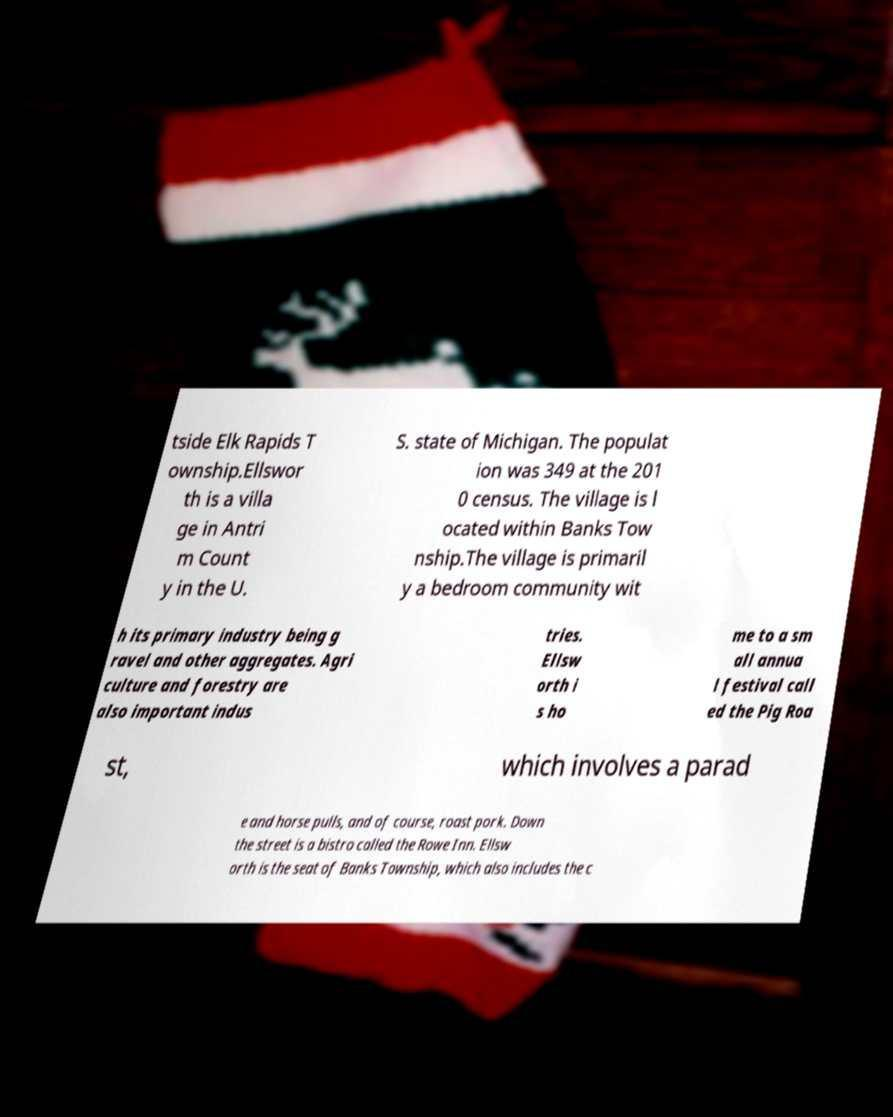Please read and relay the text visible in this image. What does it say? tside Elk Rapids T ownship.Ellswor th is a villa ge in Antri m Count y in the U. S. state of Michigan. The populat ion was 349 at the 201 0 census. The village is l ocated within Banks Tow nship.The village is primaril y a bedroom community wit h its primary industry being g ravel and other aggregates. Agri culture and forestry are also important indus tries. Ellsw orth i s ho me to a sm all annua l festival call ed the Pig Roa st, which involves a parad e and horse pulls, and of course, roast pork. Down the street is a bistro called the Rowe Inn. Ellsw orth is the seat of Banks Township, which also includes the c 